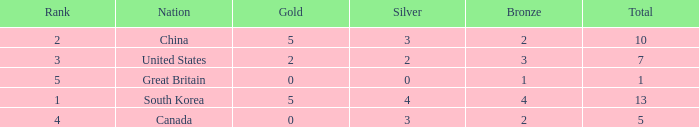What's the minimum ranking for great britain when they have less than one bronze medal? None. 